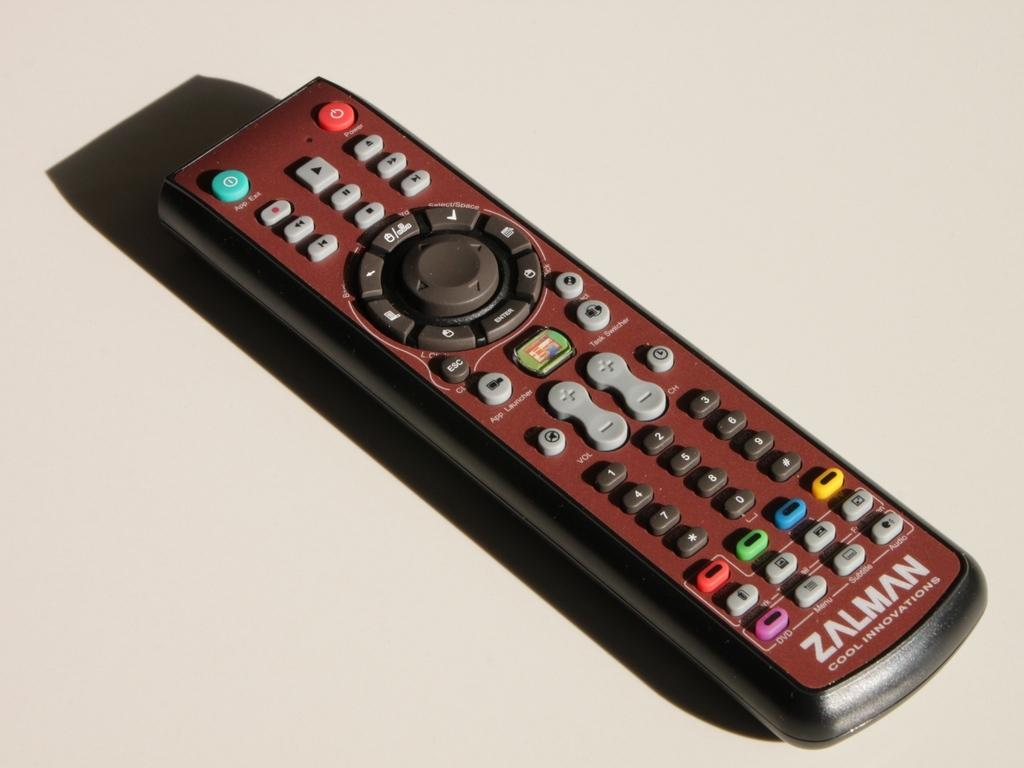<image>
Summarize the visual content of the image. A Zalman Cool Innovations remote has many buttons including DVD, Menu, and Volume. 